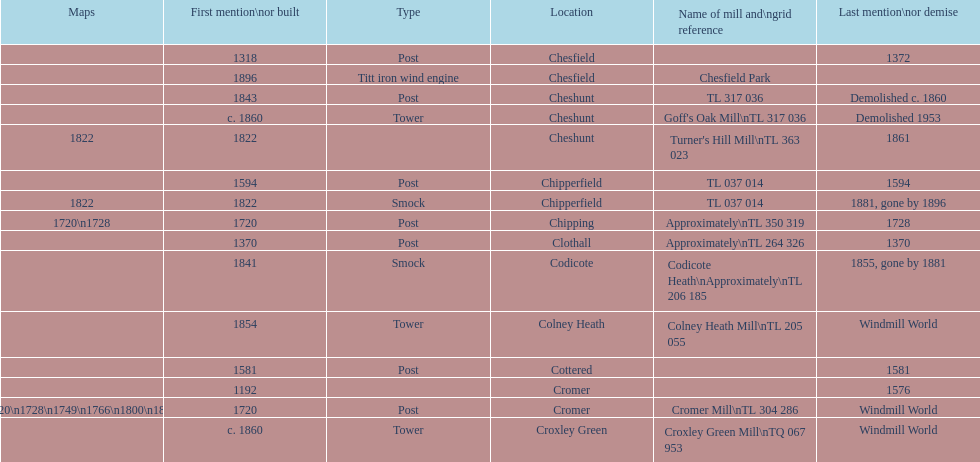How man "c" windmills have there been? 15. 